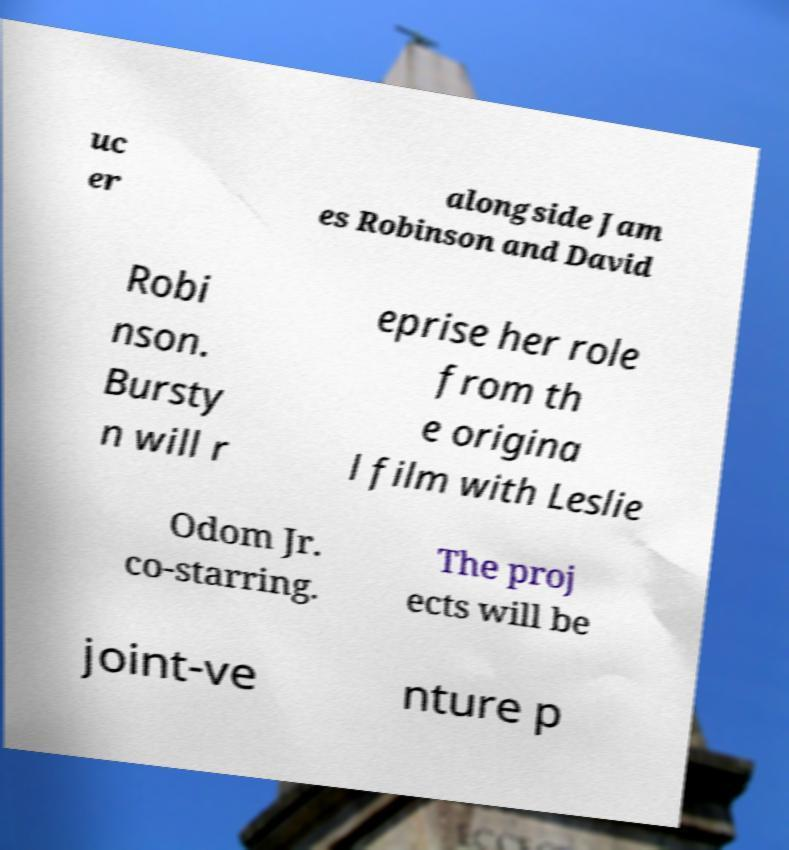There's text embedded in this image that I need extracted. Can you transcribe it verbatim? uc er alongside Jam es Robinson and David Robi nson. Bursty n will r eprise her role from th e origina l film with Leslie Odom Jr. co-starring. The proj ects will be joint-ve nture p 